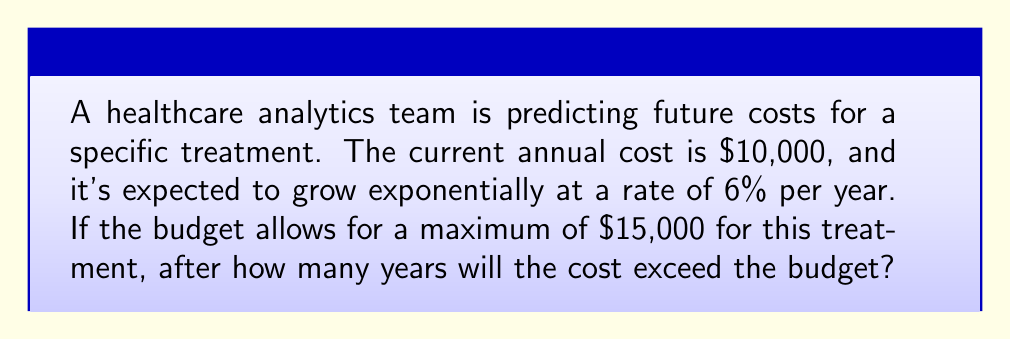Can you solve this math problem? Let's approach this step-by-step:

1) The exponential growth model is given by:
   $$A(t) = A_0 \cdot (1 + r)^t$$
   where $A(t)$ is the amount after time $t$, $A_0$ is the initial amount, $r$ is the growth rate, and $t$ is the time in years.

2) We have:
   $A_0 = 10000$ (initial cost)
   $r = 0.06$ (6% growth rate)
   We need to find $t$ when $A(t) > 15000$

3) Let's set up the inequality:
   $$10000 \cdot (1 + 0.06)^t > 15000$$

4) Divide both sides by 10000:
   $$(1.06)^t > 1.5$$

5) Take the natural log of both sides:
   $$t \cdot \ln(1.06) > \ln(1.5)$$

6) Solve for $t$:
   $$t > \frac{\ln(1.5)}{\ln(1.06)} \approx 7.84$$

7) Since we need the number of whole years, we round up to the next integer.
Answer: 8 years 